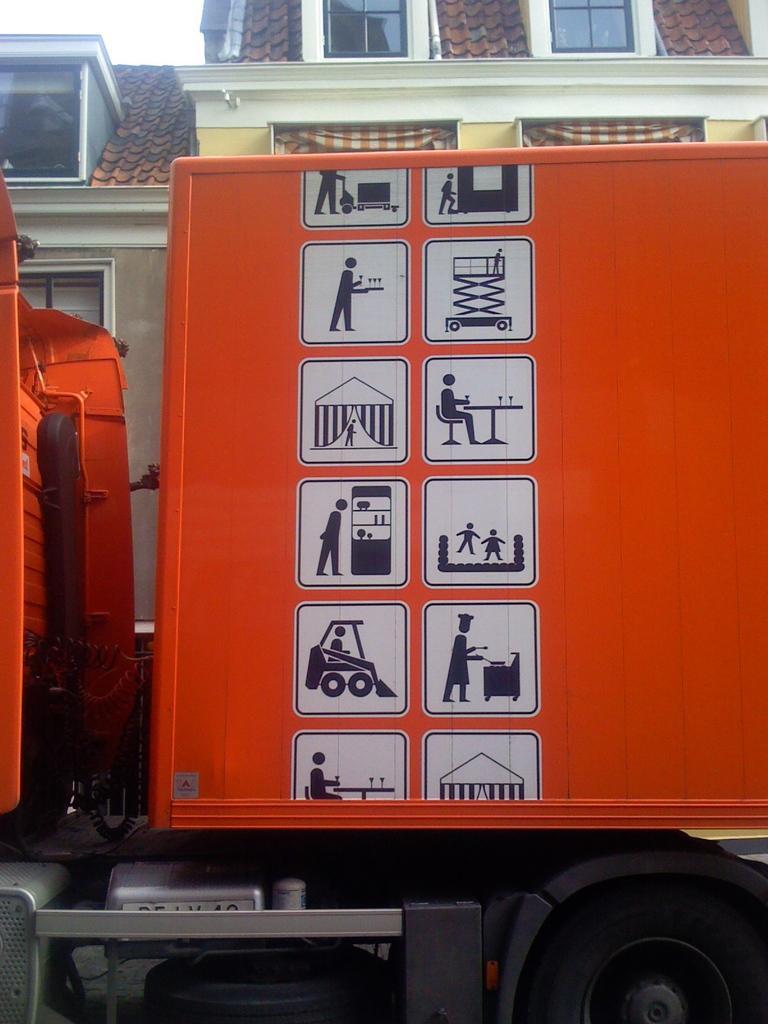Describe this image in one or two sentences. In the middle of this image, there are paintings on an orange color vehicle. In the background, there are buildings which are having windows and there is sky. 